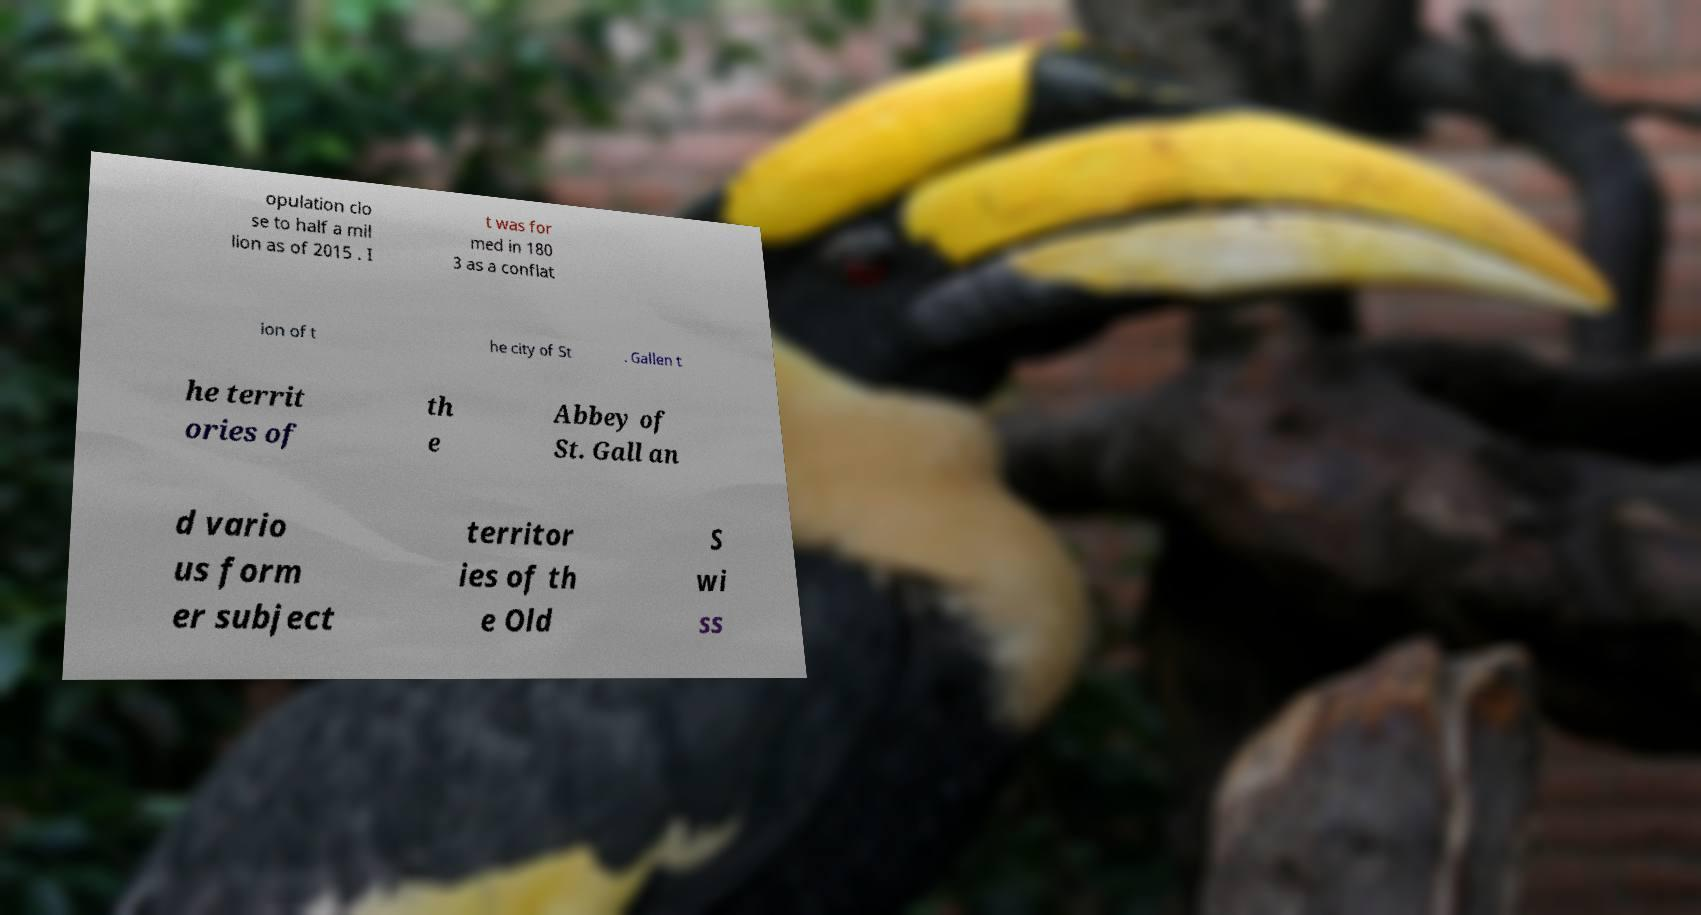What messages or text are displayed in this image? I need them in a readable, typed format. opulation clo se to half a mil lion as of 2015 . I t was for med in 180 3 as a conflat ion of t he city of St . Gallen t he territ ories of th e Abbey of St. Gall an d vario us form er subject territor ies of th e Old S wi ss 